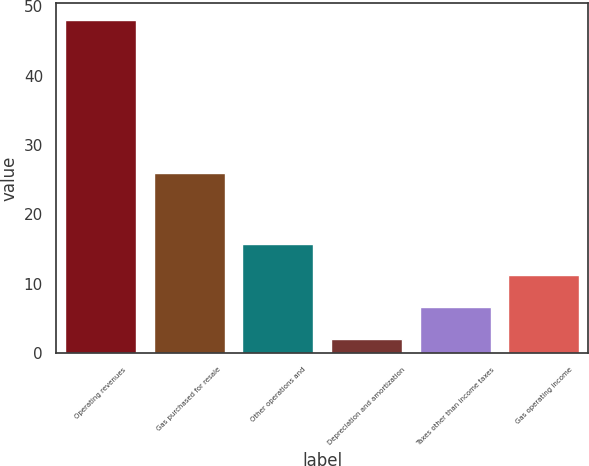Convert chart to OTSL. <chart><loc_0><loc_0><loc_500><loc_500><bar_chart><fcel>Operating revenues<fcel>Gas purchased for resale<fcel>Other operations and<fcel>Depreciation and amortization<fcel>Taxes other than income taxes<fcel>Gas operating income<nl><fcel>48<fcel>26<fcel>15.8<fcel>2<fcel>6.6<fcel>11.2<nl></chart> 